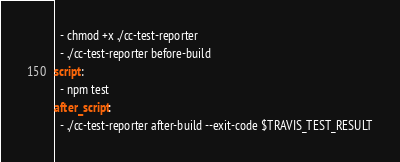<code> <loc_0><loc_0><loc_500><loc_500><_YAML_>  - chmod +x ./cc-test-reporter
  - ./cc-test-reporter before-build
script:
  - npm test
after_script:
  - ./cc-test-reporter after-build --exit-code $TRAVIS_TEST_RESULT
</code> 